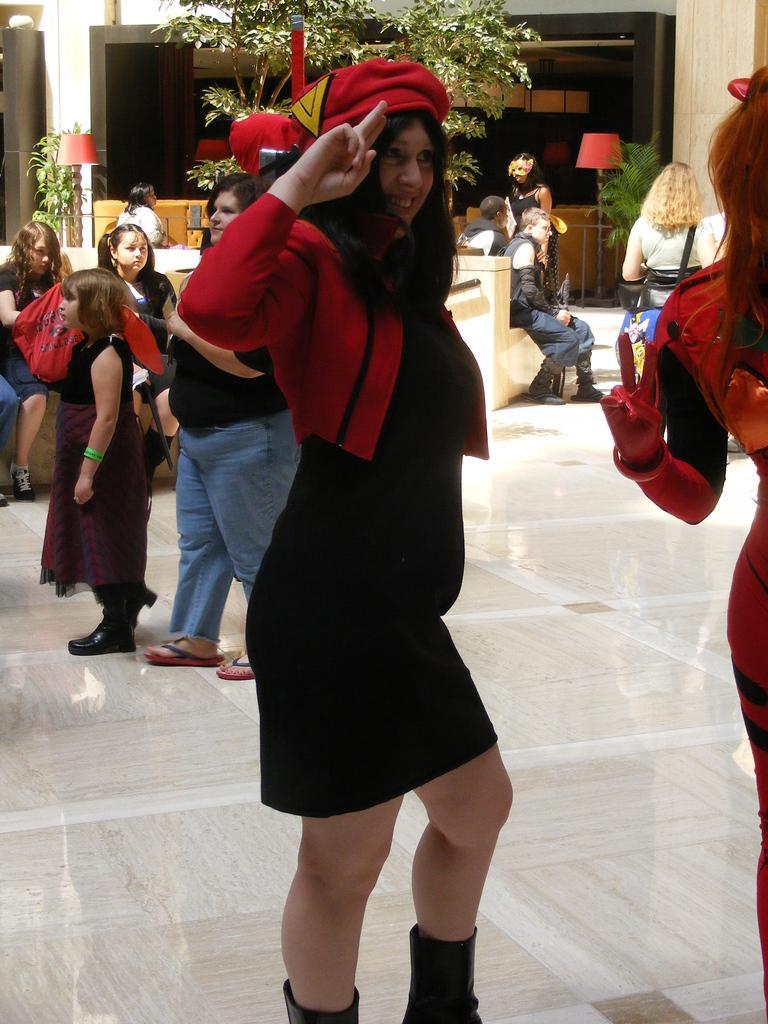How would you summarize this image in a sentence or two? In this picture we can observe a woman wearing black and red color dress. She is wearing red color cap on her head. In the background we can observe some people standing and sitting. We can observe some plants and two lamps in the background. 